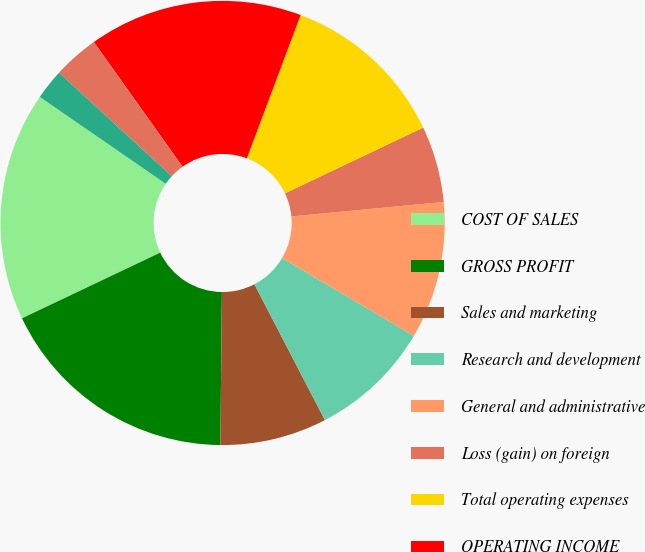<chart> <loc_0><loc_0><loc_500><loc_500><pie_chart><fcel>COST OF SALES<fcel>GROSS PROFIT<fcel>Sales and marketing<fcel>Research and development<fcel>General and administrative<fcel>Loss (gain) on foreign<fcel>Total operating expenses<fcel>OPERATING INCOME<fcel>Interest income (expense) net<fcel>Other income (expense) net<nl><fcel>16.67%<fcel>17.78%<fcel>7.78%<fcel>8.89%<fcel>10.0%<fcel>5.56%<fcel>12.22%<fcel>15.56%<fcel>3.33%<fcel>2.22%<nl></chart> 